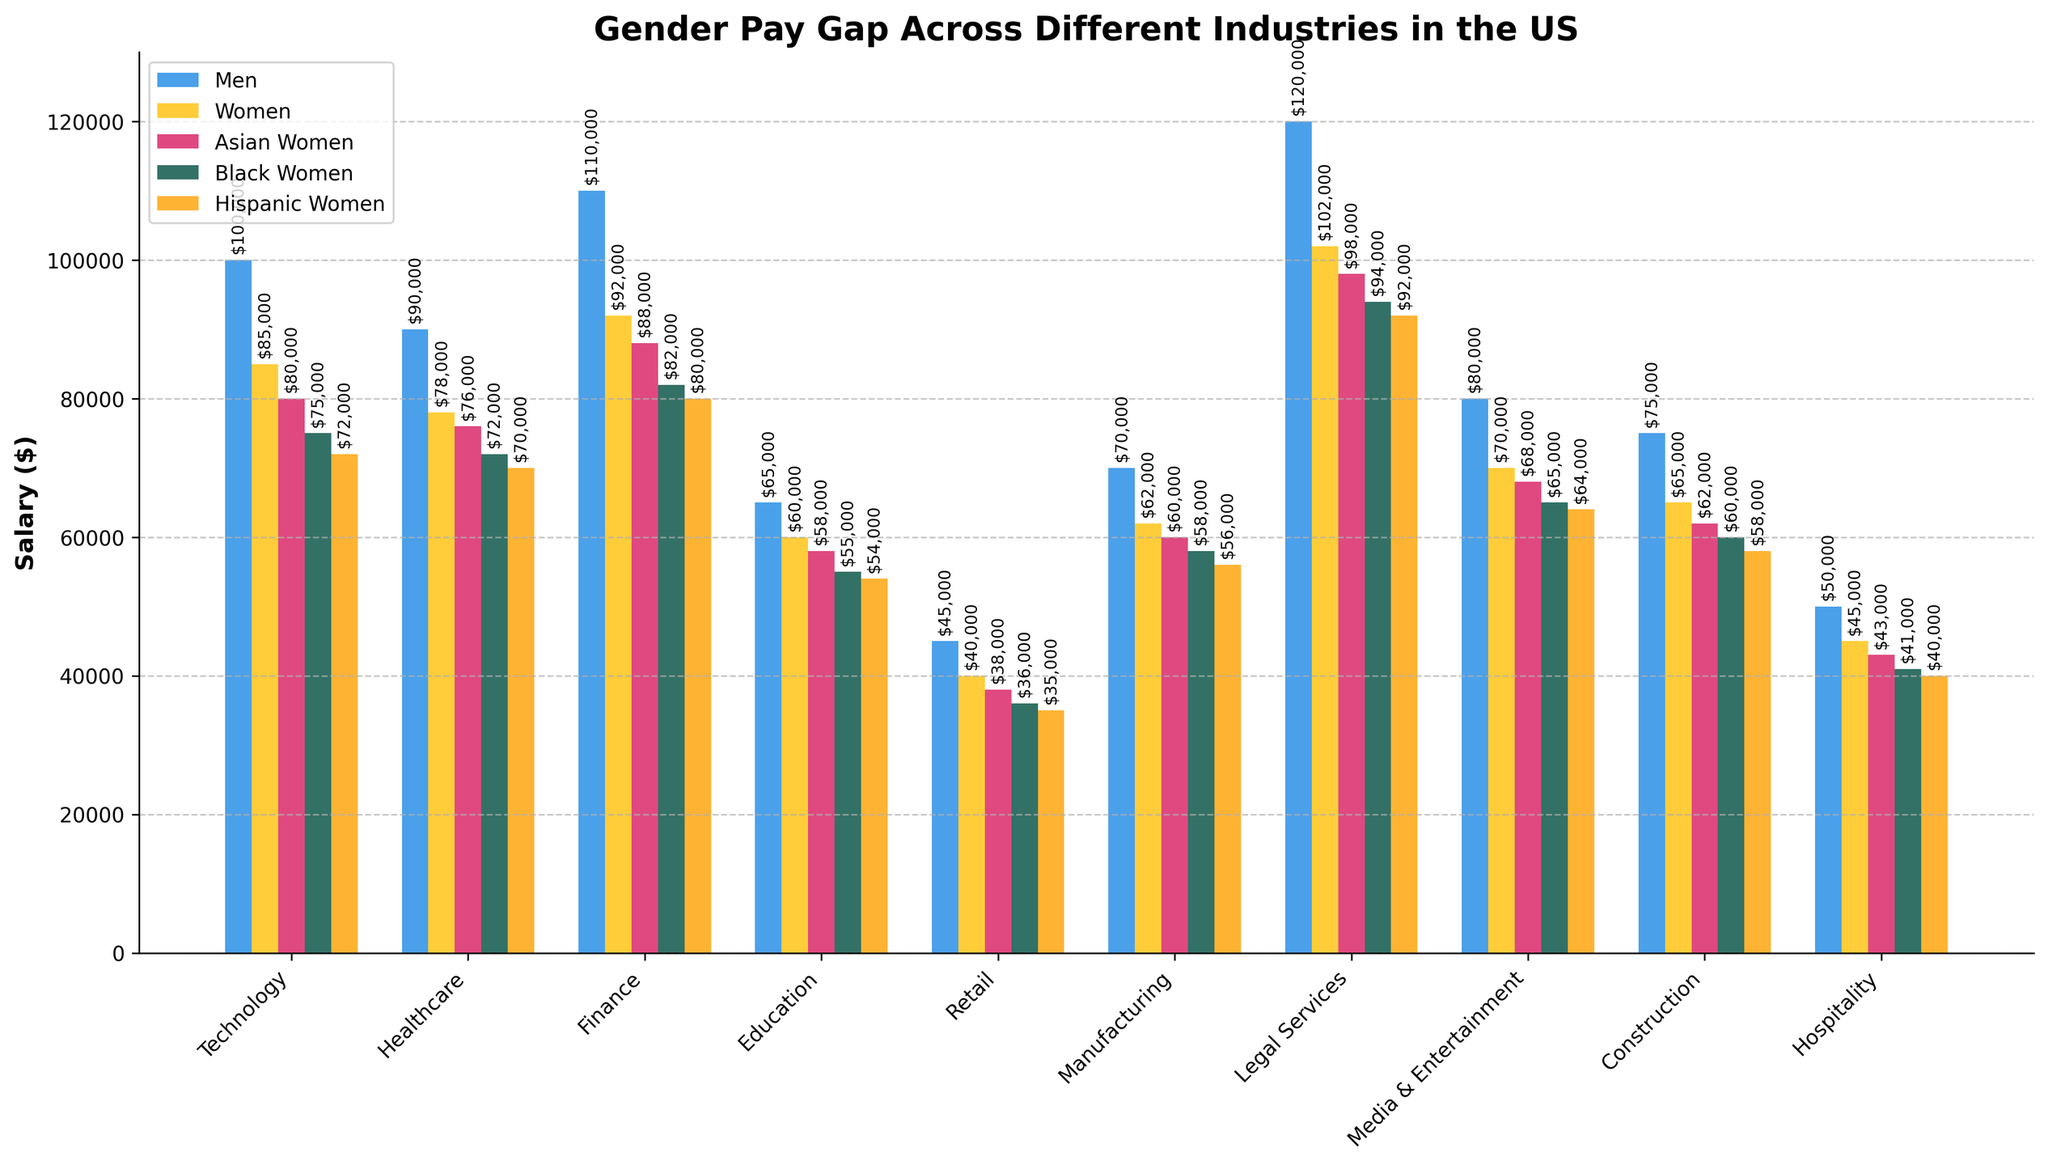Which industry has the highest salary for men? Look at the height of the bars for men across all industries. The tallest bar for men is in the "Legal Services" industry.
Answer: Legal Services What is the salary difference between men and women in the Finance industry? Find the heights of the bars for men and women in the Finance industry. Subtract the women's salary ($92,000) from the men's salary ($110,000).
Answer: $18,000 Among Asian, Black, and Hispanic women, who earns the least in the Technology industry? Compare the heights of the bars labelled for Asian Women, Black Women, and Hispanic Women in the Technology industry. The shortest bar among them is for Hispanic Women.
Answer: Hispanic Women Which group has the smallest salary in the Education industry? Look at the height of all bars in the Education industry. The shortest bar belongs to Hispanic Women.
Answer: Hispanic Women How much more do Black Women earn compared to Hispanic Women in the Healthcare industry? Look at the heights of the bars for Black Women and Hispanic Women in Healthcare. Subtract the Hispanic Women's salary ($70,000) from the Black Women's salary ($72,000).
Answer: $2,000 In the Construction industry, what’s the average salary of women (including Asian, Black, and Hispanic women)? Add the salaries of Women ($65,000), Asian Women ($62,000), Black Women ($60,000), and Hispanic Women ($58,000). Then divide by 4 to get the average. Calculation: ($65,000 + $62,000 + $60,000 + $58,000) / 4 = $61,250.
Answer: $61,250 Which industry shows the smallest gender pay gap between men and women? Calculate the differences between men's and women's salaries in each industry. Compare the differences to find the smallest one. The smallest gender pay gap is in the Education industry ($65,000 - $60,000 = $5,000).
Answer: Education Which two industries have the closest salaries for Black Women? Compare the heights of the bars for Black Women across all industries to find the two closest bars. The closest salaries are in Hospitality ($41,000) and Retail ($36,000), a difference of $5,000.
Answer: Hospitality and Retail In which industry do Asian Women earn more than Black Women but less than Men? Compare the heights of the bars for Asian Women, Black Women, and Men in each industry. In Finance, Asian Women earn $88,000 which is more than Black Women ($82,000) but less than Men ($110,000).
Answer: Finance 